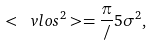Convert formula to latex. <formula><loc_0><loc_0><loc_500><loc_500>\ < \ v l o s ^ { 2 } > = \frac { \pi } { / } 5 \sigma ^ { 2 } ,</formula> 